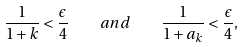<formula> <loc_0><loc_0><loc_500><loc_500>\frac { 1 } { 1 + k } < \frac { \epsilon } { 4 } \quad a n d \quad \frac { 1 } { 1 + a _ { k } } < \frac { \epsilon } { 4 } ,</formula> 